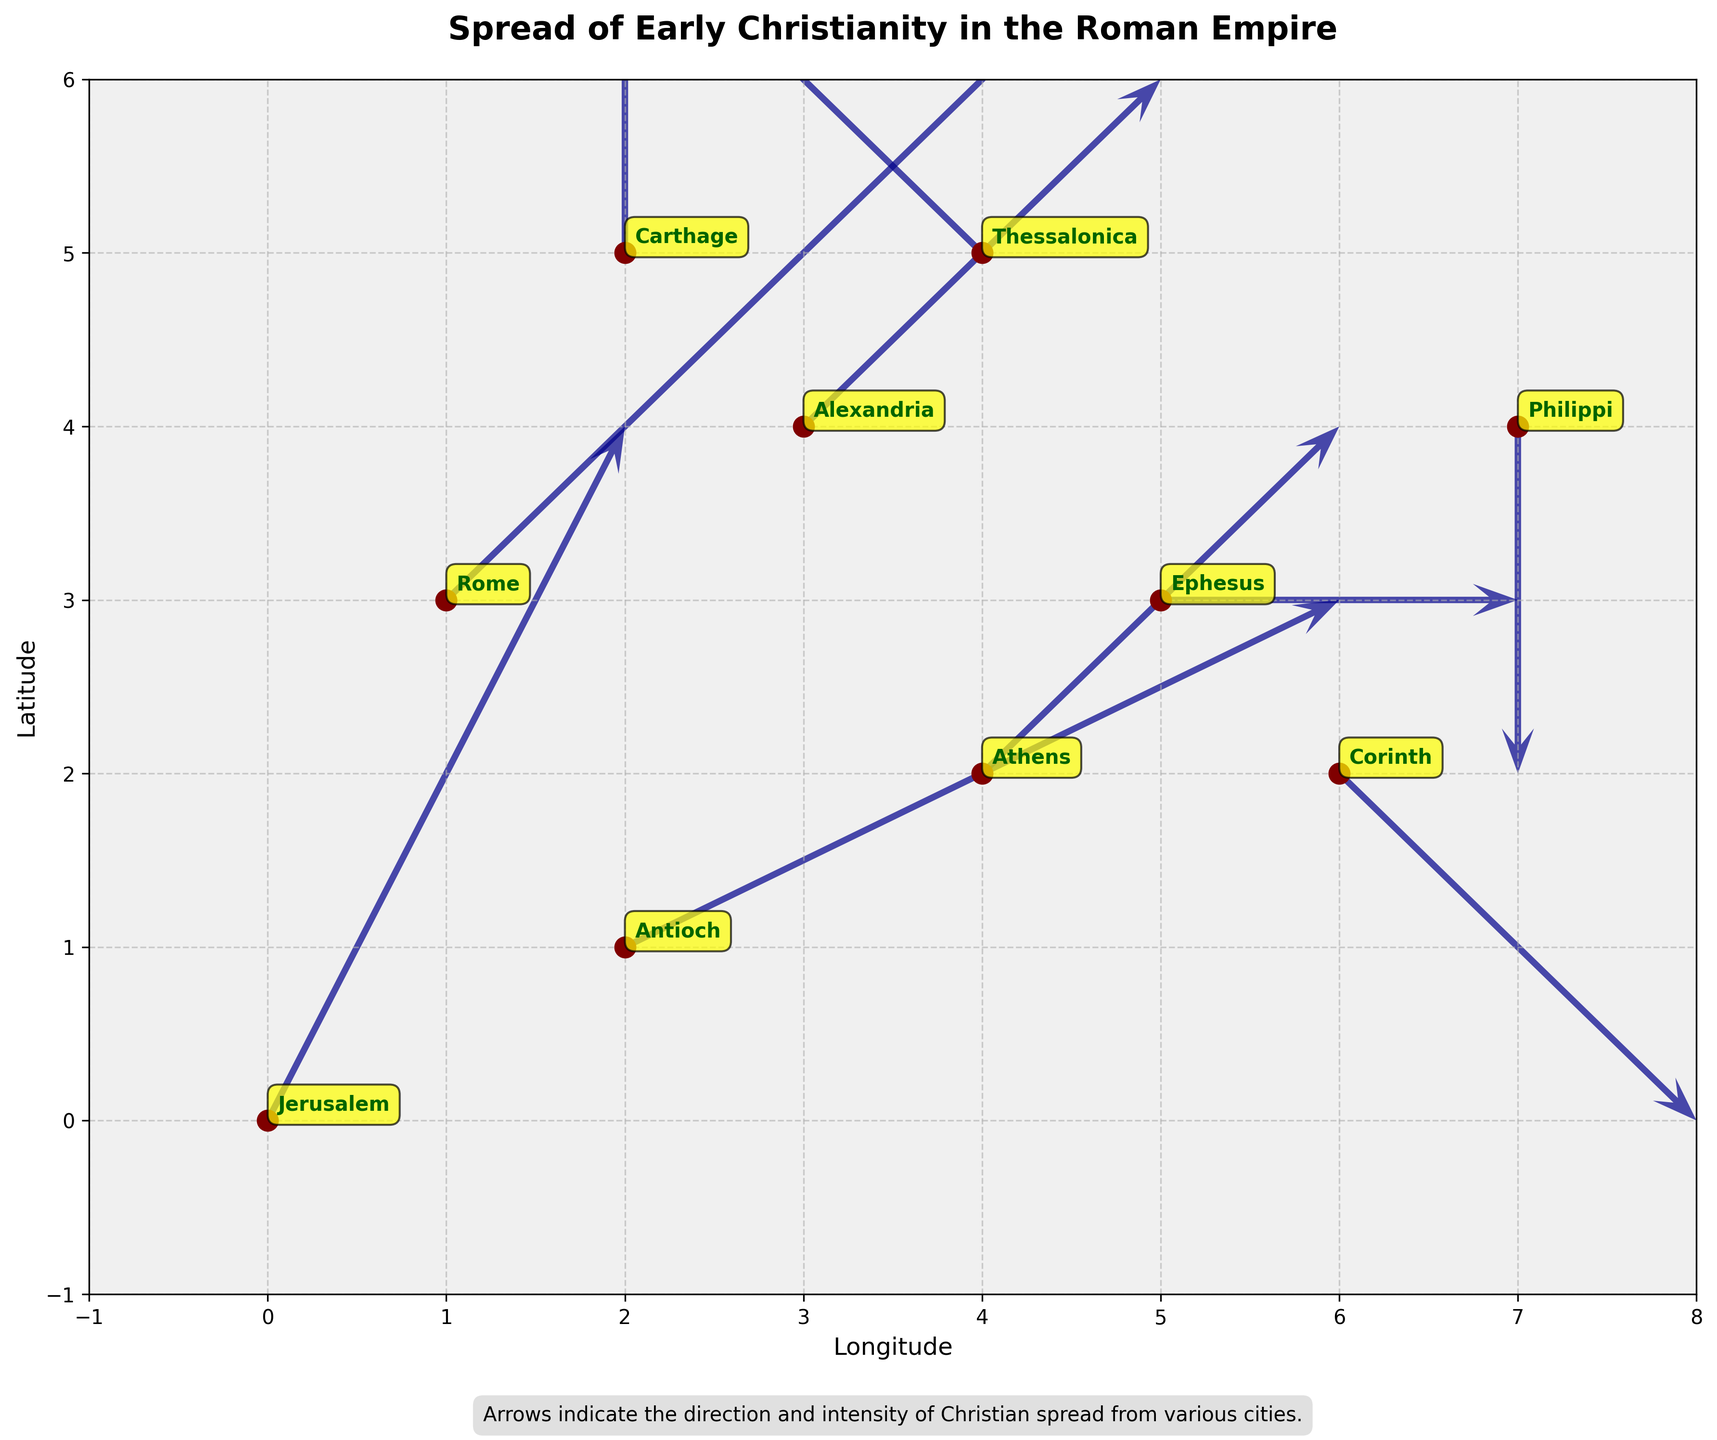What's the title of the plot? The title is usually written at the top of the plot. Here, it's located centrally and uses a bold font to capture attention.
Answer: Spread of Early Christianity in the Roman Empire How many cities are marked on the map? The scatter plot includes points representing cities. Count these maroon points to find the number of cities.
Answer: 10 Which city is located at coordinates (6, 2)? Locate the point where x=6 and y=2 on the map and read the nearby annotation for the city's name.
Answer: Corinth What does the direction of arrows represent? The text under the plot explains the arrows. It says, "Arrows indicate the direction and intensity of Christian spread from various cities."
Answer: The direction and intensity of Christian spread Which city has the longest vector indicating the spread of Christianity? Compare the lengths of the arrows. The longest arrow extends from the origin point to the end point.
Answer: Jerusalem In which direction did Christianity spread from Athens? Look at the vector originating from Athens and check its direction. The arrow at (4,2) points right and up.
Answer: Right and up Which city shows the largest downward spread of Christianity? Identify the arrows pointing downward and check which one points the farthest down. Only the arrow from Corinth points somewhat down.
Answer: Corinth Compare the spread intensity between Rome and Carthage. Which city shows more intense spread? Look at the arrows originating from both cities. The length of the arrow represents intensity; Rome's vector is longer.
Answer: Rome Are there any cities where the spread of Christianity has no horizontal component? Look for vectors where the horizontal component (u) is zero. Carthage and Philippi have arrows with no horizontal spread.
Answer: Carthage, Philippi 